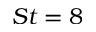<formula> <loc_0><loc_0><loc_500><loc_500>S t = 8</formula> 